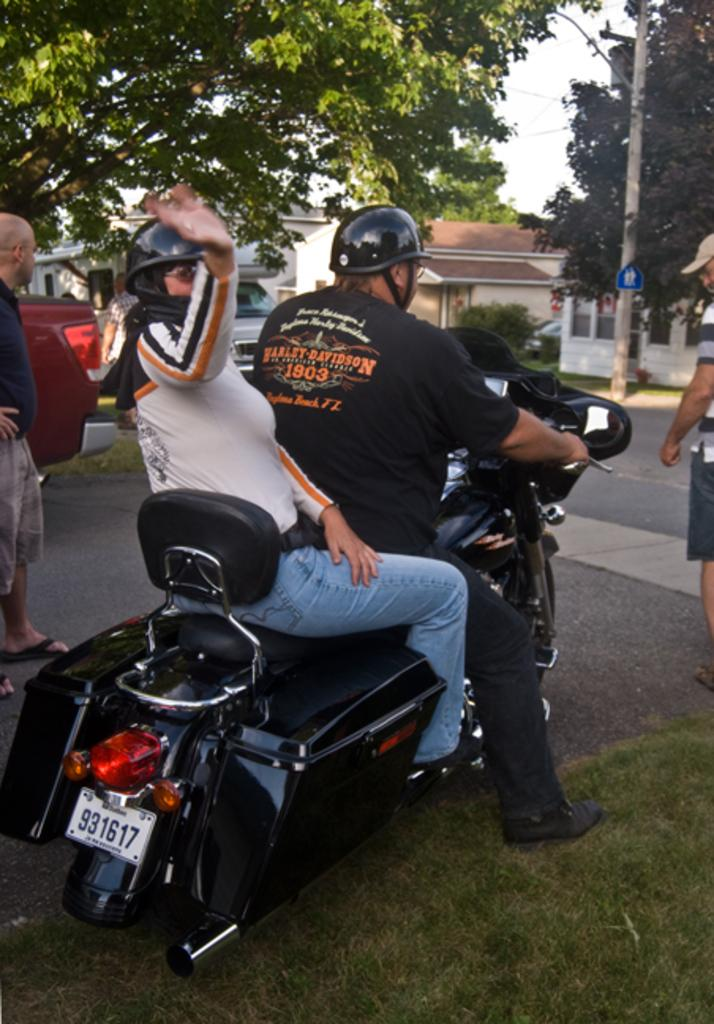How many people are on the bike in the image? There are two persons on a bike in the image. What is the gender of the people in the image? The persons in the image are men. Where are the men and the bike located? They are on a path. What can be seen in the background of the image? Cars, trees, and houses are visible in the background. What type of support can be seen holding up the bridge in the image? There is no bridge present in the image, so there is no support to be seen. What kind of oatmeal is being served to the men in the image? There is no oatmeal present in the image; the men are on a bike. 